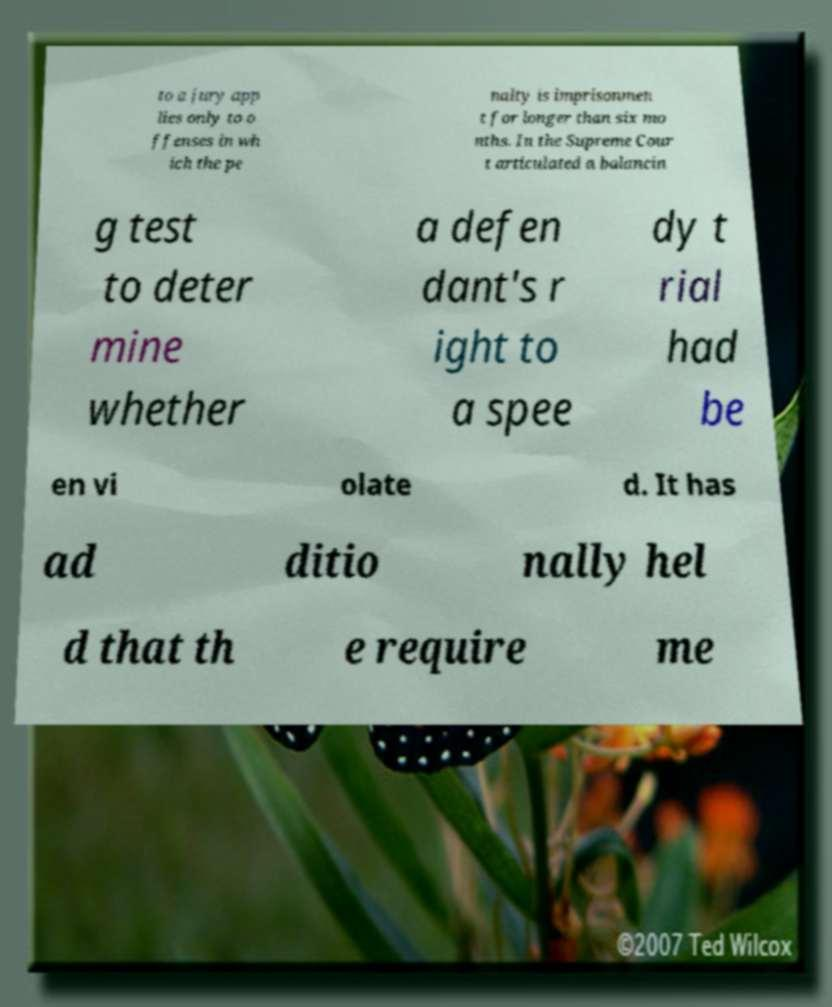Please read and relay the text visible in this image. What does it say? to a jury app lies only to o ffenses in wh ich the pe nalty is imprisonmen t for longer than six mo nths. In the Supreme Cour t articulated a balancin g test to deter mine whether a defen dant's r ight to a spee dy t rial had be en vi olate d. It has ad ditio nally hel d that th e require me 